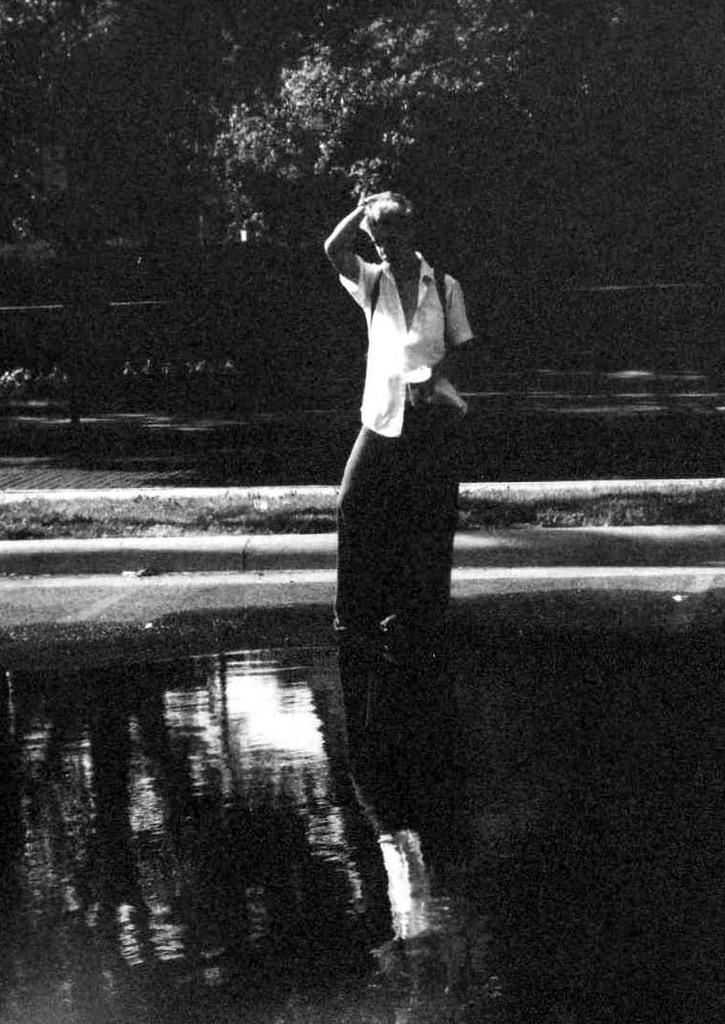What is the color scheme of the image? The image is black and white. Can you describe the person in the image? There is a person in the image, and they are wearing a bag. What is the person's location in the image? The person is standing in the water. What can be seen in the background of the image? There are trees visible in the background of the image. How many feet of land are visible in the image? The image is black and white and does not show any land, so it is not possible to determine the number of feet of land visible. 